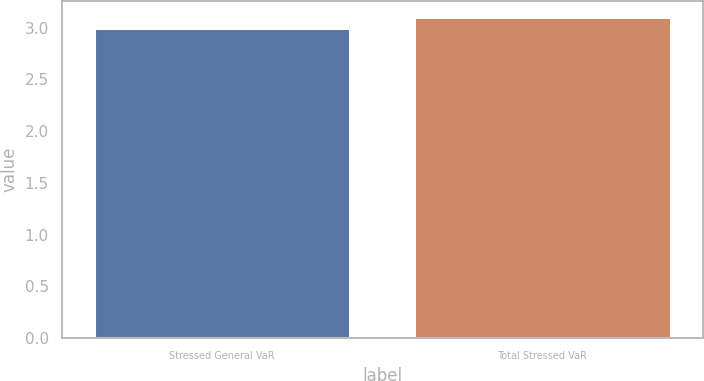Convert chart. <chart><loc_0><loc_0><loc_500><loc_500><bar_chart><fcel>Stressed General VaR<fcel>Total Stressed VaR<nl><fcel>3<fcel>3.1<nl></chart> 